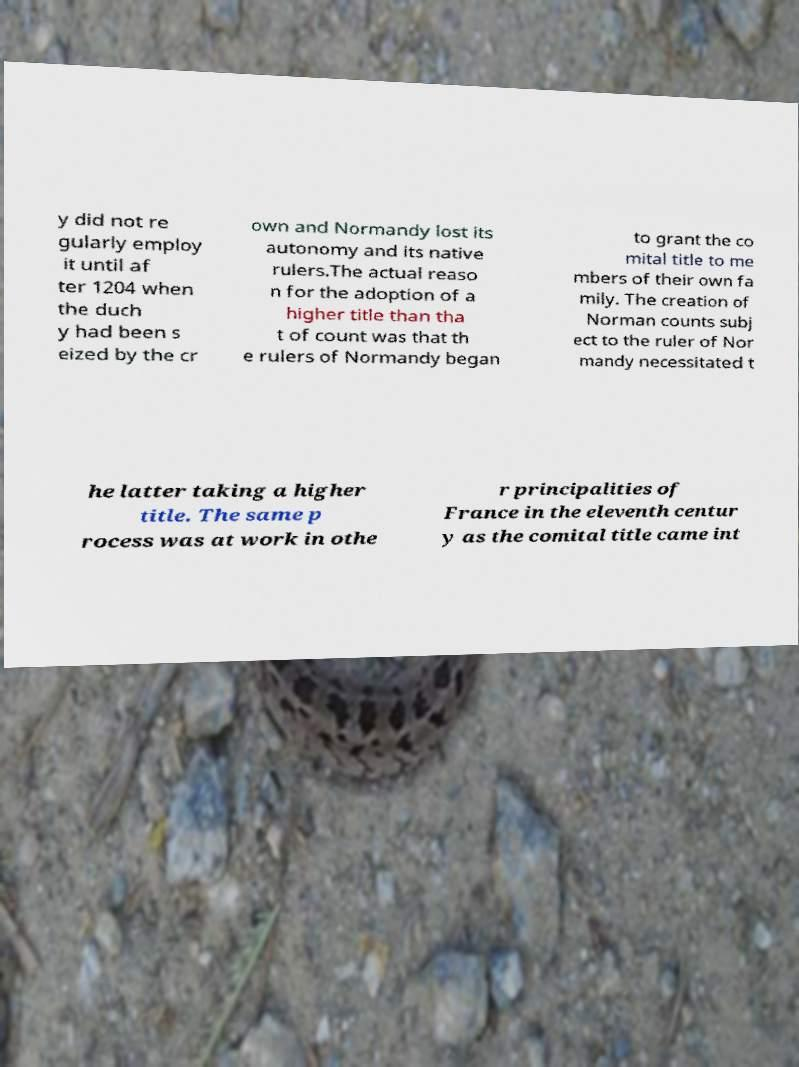There's text embedded in this image that I need extracted. Can you transcribe it verbatim? y did not re gularly employ it until af ter 1204 when the duch y had been s eized by the cr own and Normandy lost its autonomy and its native rulers.The actual reaso n for the adoption of a higher title than tha t of count was that th e rulers of Normandy began to grant the co mital title to me mbers of their own fa mily. The creation of Norman counts subj ect to the ruler of Nor mandy necessitated t he latter taking a higher title. The same p rocess was at work in othe r principalities of France in the eleventh centur y as the comital title came int 